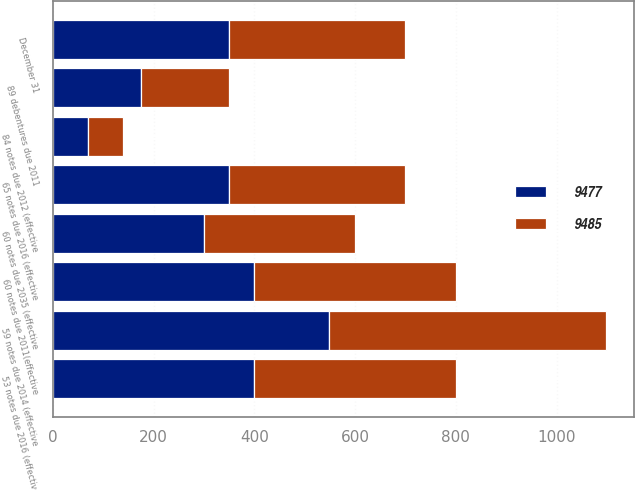Convert chart. <chart><loc_0><loc_0><loc_500><loc_500><stacked_bar_chart><ecel><fcel>December 31<fcel>89 debentures due 2011<fcel>53 notes due 2016 (effective<fcel>60 notes due 2035 (effective<fcel>60 notes due 2011(effective<fcel>84 notes due 2012 (effective<fcel>59 notes due 2014 (effective<fcel>65 notes due 2016 (effective<nl><fcel>9485<fcel>350<fcel>175<fcel>400<fcel>300<fcel>400<fcel>70<fcel>549<fcel>350<nl><fcel>9477<fcel>350<fcel>175<fcel>400<fcel>300<fcel>400<fcel>70<fcel>549<fcel>350<nl></chart> 